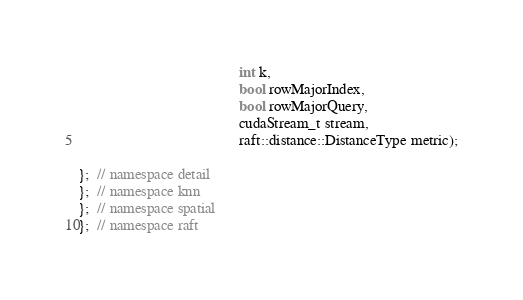Convert code to text. <code><loc_0><loc_0><loc_500><loc_500><_Cuda_>                                           int k,
                                           bool rowMajorIndex,
                                           bool rowMajorQuery,
                                           cudaStream_t stream,
                                           raft::distance::DistanceType metric);

};  // namespace detail
};  // namespace knn
};  // namespace spatial
};  // namespace raft
</code> 